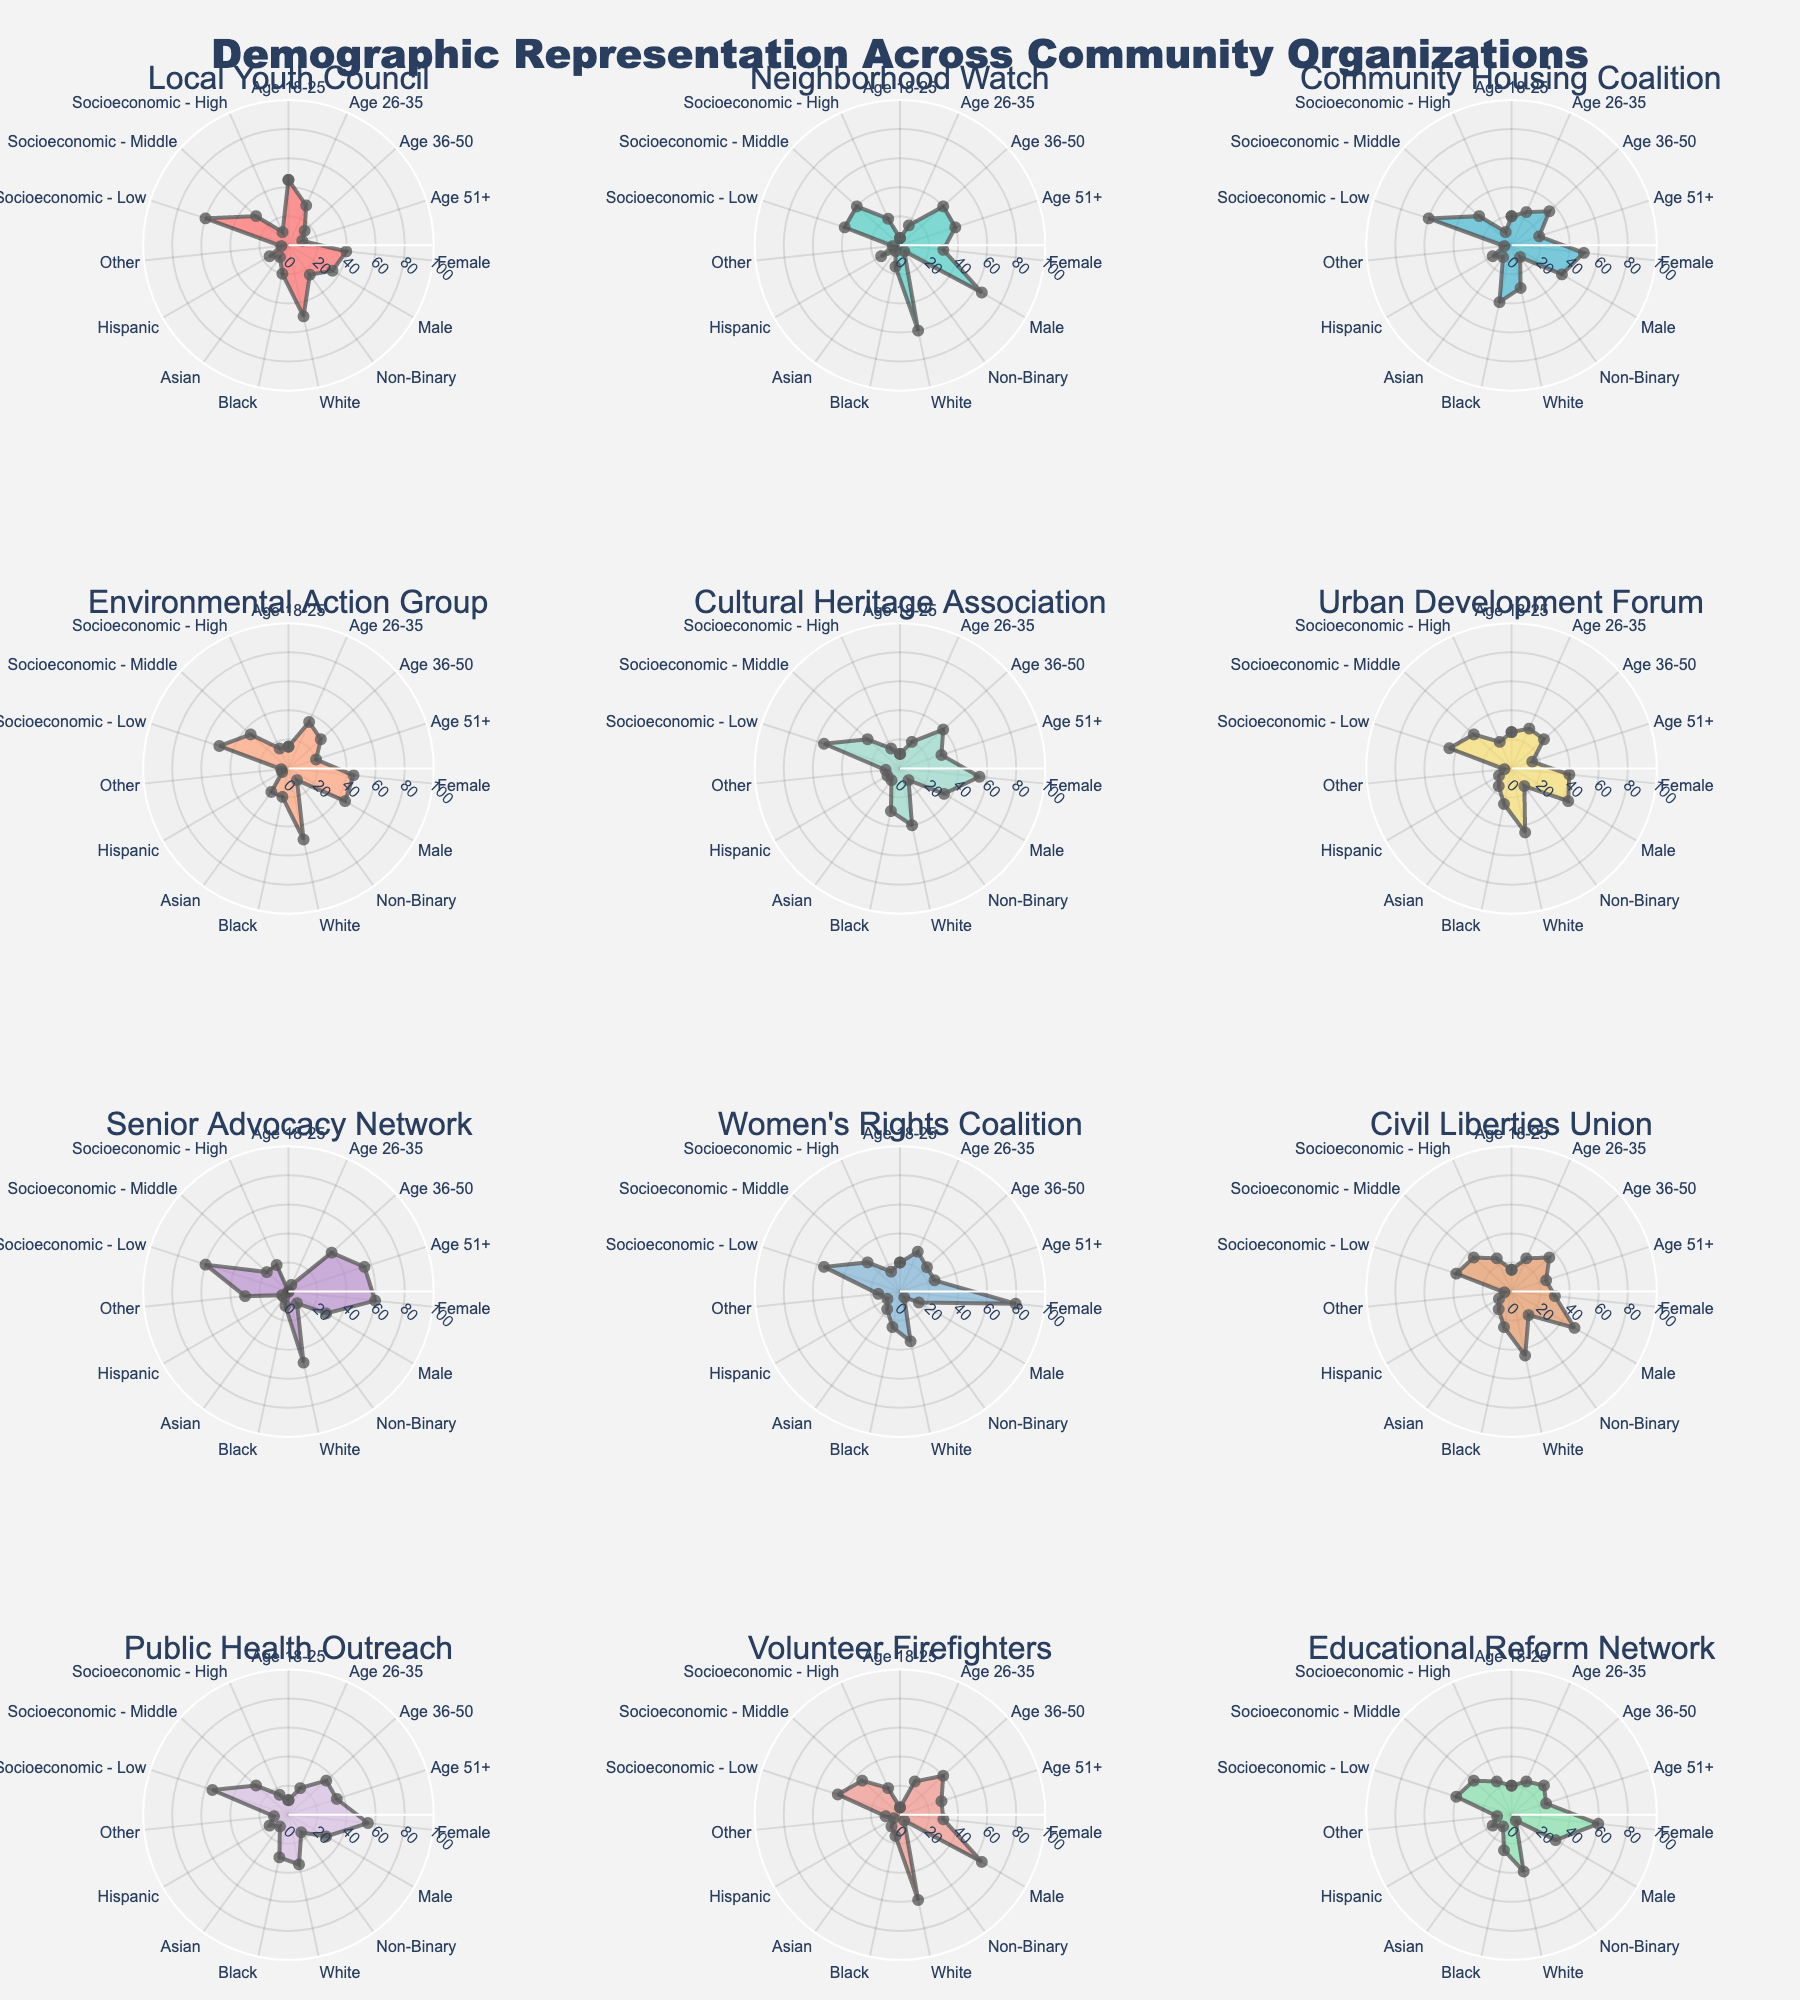What is the title of the figure? The title is located at the top of the figure. It is clearly stated within the title area, usually means it is aimed at summarizing the overall content of the chart.
Answer: Demographic Representation Across Community Organizations Which organization has the highest percentage of females? By examining the "Female" axis across all subplots, the organization with the highest value can be identified.
Answer: Women's Rights Coalition Which age group is most prominently represented in the Senior Advocacy Network? Looking closely at the Senior Advocacy Network’s radar chart, identify which age group has the highest radial value.
Answer: Age 51+ Compare the representation of Asian individuals across the Neighborhood Watch and Volunteer Firefighters subplots. Which organization has a higher percentage? Review both subplots for the specified organizations and focus on the "Asian" axis to compare their values.
Answer: Volunteer Firefighters What proportion of the Environmental Action Group identifies as Male versus Non-Binary? Locate the "Male" and "Non-Binary" axes on the Environmental Action Group’s radar chart and compare their values.
Answer: 45 versus 10 Which organization has the most balanced gender representation between Male and Female members? Assess all subplots and identify the organization where the values on "Male" and "Female" axes are closest to each other.
Answer: Civil Liberties Union How does the Socioeconomic - Low representation in the Educational Reform Network compare to the Socioeconomic - High representation? Refer to the "Socioeconomic - Low" and "Socioeconomic - High" axes on the Educational Reform Network's radar chart and compare these values.
Answer: 40 versus 25 What is the ethnic diversity distribution in the Cultural Heritage Association? Examine the Cultural Heritage Association subplot and observe the values along the axes labeled "White," "Black," "Asian," "Hispanic," and "Other."
Answer: 40% White, 30% Black, 10% Asian, 10% Hispanic, 10% Other Which age group is least represented in the Urban Development Forum, and what is its percentage? Use the Urban Development Forum’s radar chart and identify the age group with the smallest radial value.
Answer: Age 51+, 15% What is the overall socioeconomic composition of the Community Housing Coalition? Sum or analyze the values along "Socioeconomic - Low," "Socioeconomic - Middle," and "Socioeconomic - High" axes to describe the socioeconomic distribution.
Answer: 60% Low, 30% Middle, 10% High 